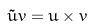Convert formula to latex. <formula><loc_0><loc_0><loc_500><loc_500>\tilde { u } v = u \times v</formula> 